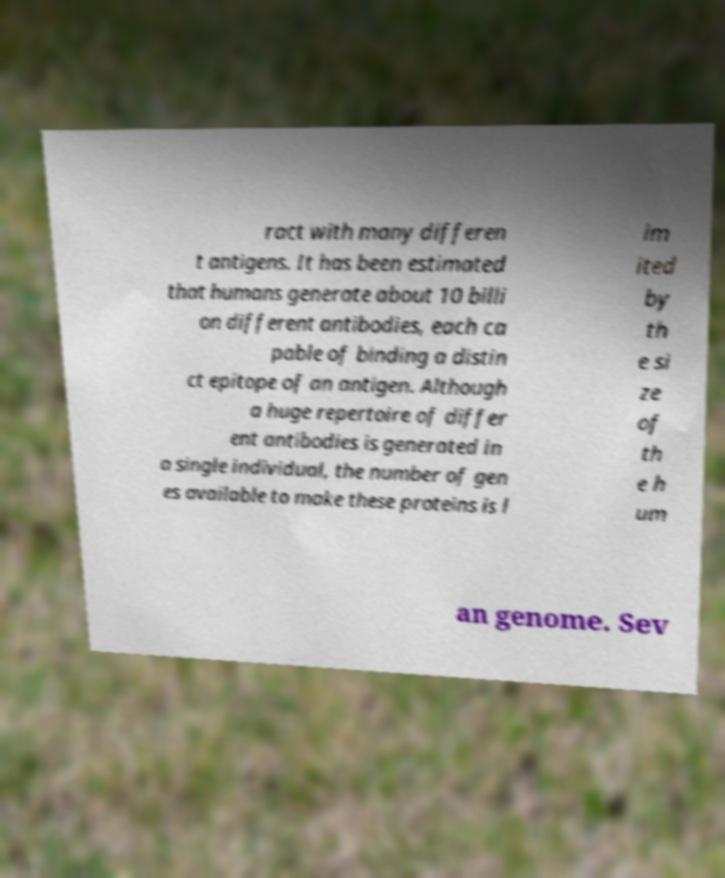Can you accurately transcribe the text from the provided image for me? ract with many differen t antigens. It has been estimated that humans generate about 10 billi on different antibodies, each ca pable of binding a distin ct epitope of an antigen. Although a huge repertoire of differ ent antibodies is generated in a single individual, the number of gen es available to make these proteins is l im ited by th e si ze of th e h um an genome. Sev 